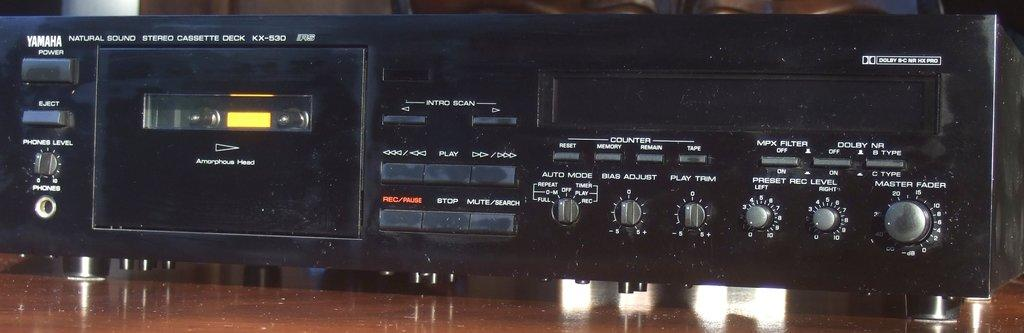<image>
Offer a succinct explanation of the picture presented. On a wooden surface there is an old fashioned, Yamaha, Natural Sound Stereo Cassette Deck. 